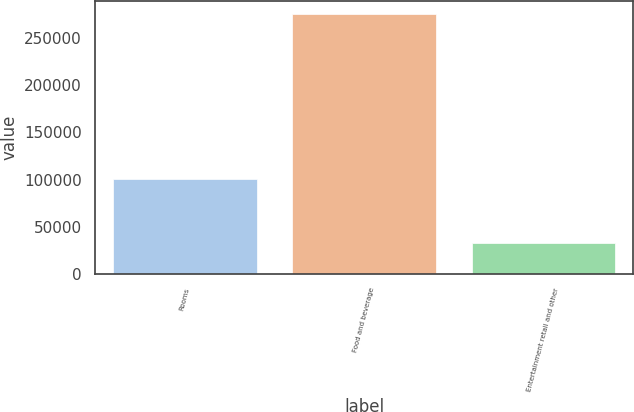<chart> <loc_0><loc_0><loc_500><loc_500><bar_chart><fcel>Rooms<fcel>Food and beverage<fcel>Entertainment retail and other<nl><fcel>100968<fcel>274776<fcel>32705<nl></chart> 